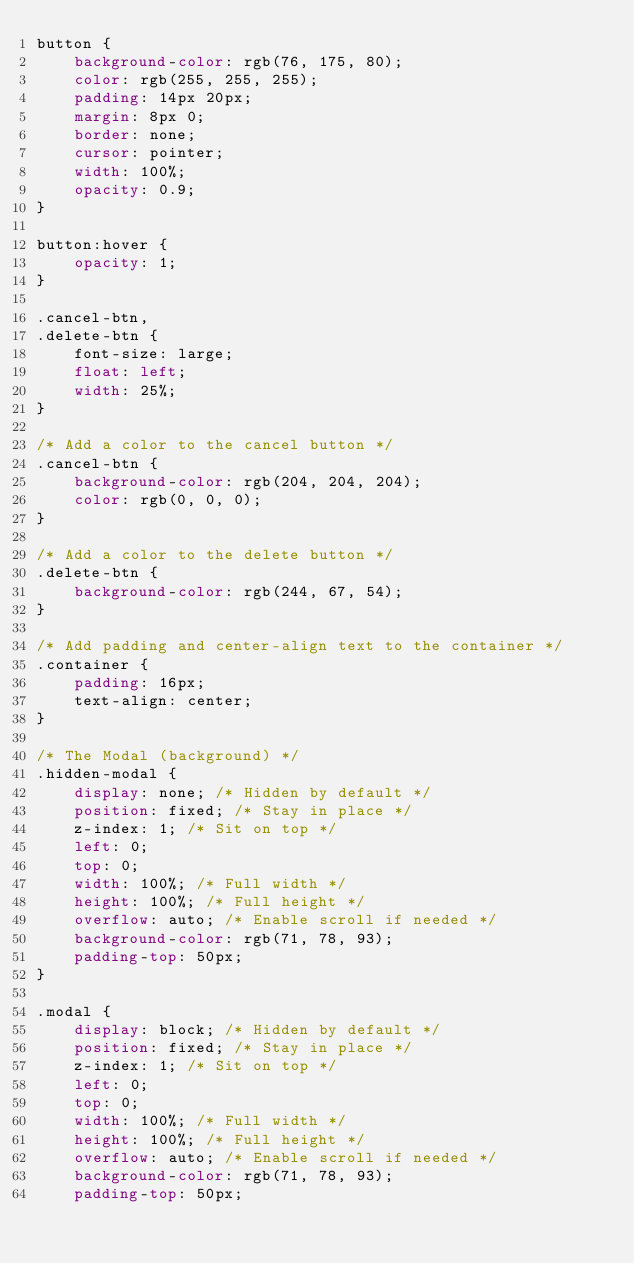Convert code to text. <code><loc_0><loc_0><loc_500><loc_500><_CSS_>button {
	background-color: rgb(76, 175, 80);
	color: rgb(255, 255, 255);
	padding: 14px 20px;
	margin: 8px 0;
	border: none;
	cursor: pointer;
	width: 100%;
	opacity: 0.9;
}

button:hover {
	opacity: 1;
}

.cancel-btn,
.delete-btn {
	font-size: large;
	float: left;
	width: 25%;
}

/* Add a color to the cancel button */
.cancel-btn {
	background-color: rgb(204, 204, 204);
	color: rgb(0, 0, 0);
}

/* Add a color to the delete button */
.delete-btn {
	background-color: rgb(244, 67, 54);
}

/* Add padding and center-align text to the container */
.container {
	padding: 16px;
	text-align: center;
}

/* The Modal (background) */
.hidden-modal {
	display: none; /* Hidden by default */
	position: fixed; /* Stay in place */
	z-index: 1; /* Sit on top */
	left: 0;
	top: 0;
	width: 100%; /* Full width */
	height: 100%; /* Full height */
	overflow: auto; /* Enable scroll if needed */
	background-color: rgb(71, 78, 93);
	padding-top: 50px;
}

.modal {
	display: block; /* Hidden by default */
	position: fixed; /* Stay in place */
	z-index: 1; /* Sit on top */
	left: 0;
	top: 0;
	width: 100%; /* Full width */
	height: 100%; /* Full height */
	overflow: auto; /* Enable scroll if needed */
	background-color: rgb(71, 78, 93);
	padding-top: 50px;</code> 